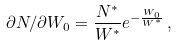Convert formula to latex. <formula><loc_0><loc_0><loc_500><loc_500>\partial N / \partial W _ { 0 } = \frac { N ^ { * } } { W ^ { * } } e ^ { - \frac { W _ { 0 } } { W ^ { * } } } \, ,</formula> 